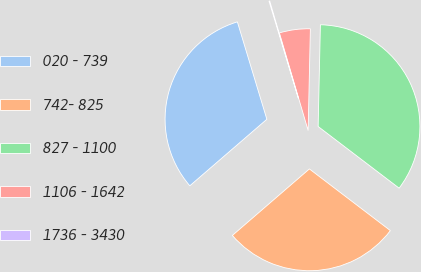Convert chart. <chart><loc_0><loc_0><loc_500><loc_500><pie_chart><fcel>020 - 739<fcel>742- 825<fcel>827 - 1100<fcel>1106 - 1642<fcel>1736 - 3430<nl><fcel>31.66%<fcel>28.31%<fcel>35.01%<fcel>4.91%<fcel>0.12%<nl></chart> 